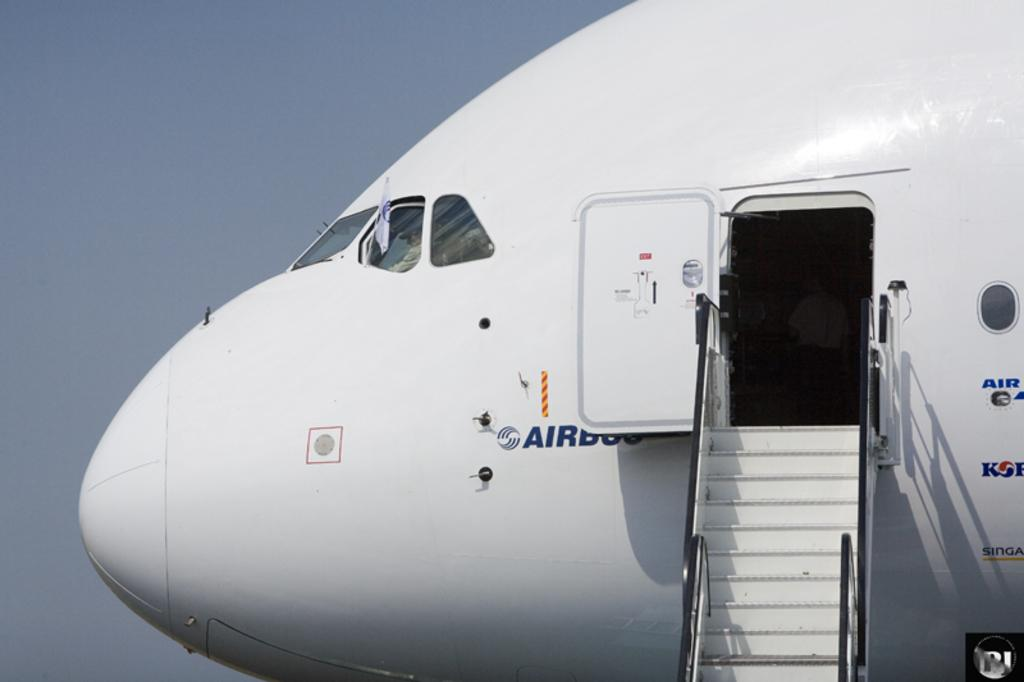What is the main subject of the image? There is a plane in the image. What can be seen in the background of the image? The sky is visible behind the plane. What song is being sung by the passengers on the plane in the image? There is no indication in the image that passengers are singing a song, so it cannot be determined from the picture. 